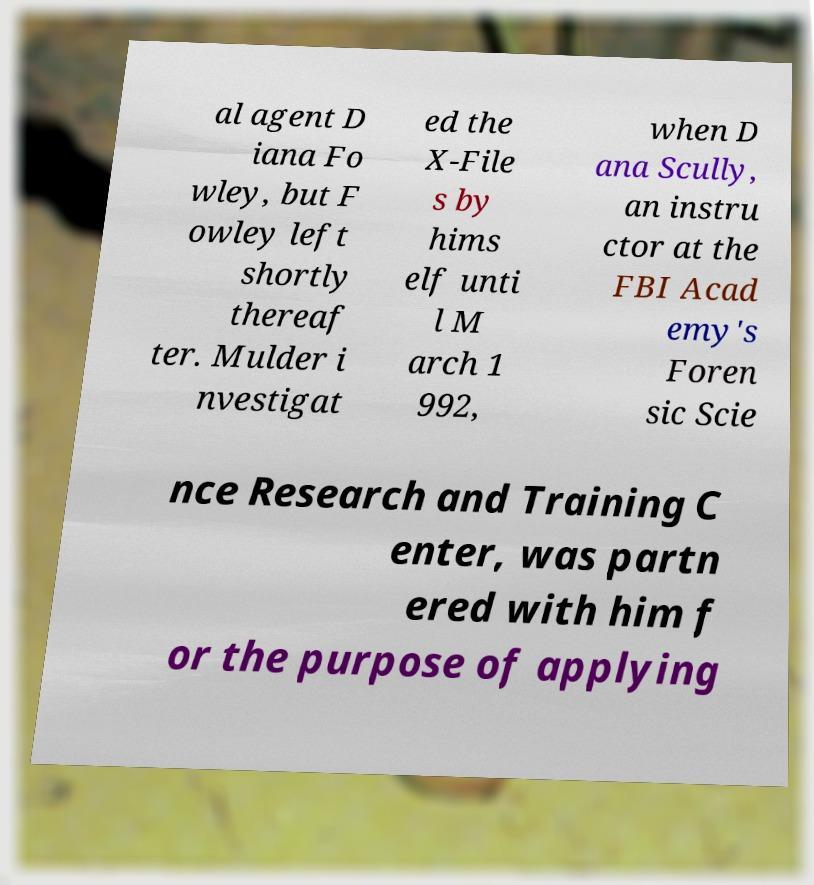Please identify and transcribe the text found in this image. al agent D iana Fo wley, but F owley left shortly thereaf ter. Mulder i nvestigat ed the X-File s by hims elf unti l M arch 1 992, when D ana Scully, an instru ctor at the FBI Acad emy's Foren sic Scie nce Research and Training C enter, was partn ered with him f or the purpose of applying 